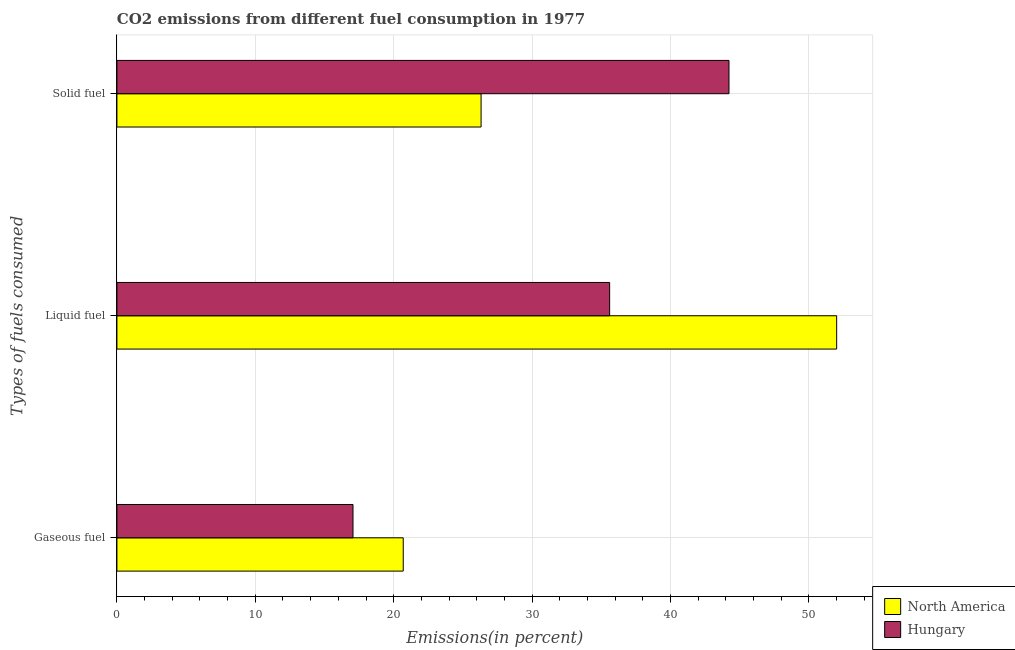How many different coloured bars are there?
Provide a succinct answer. 2. Are the number of bars per tick equal to the number of legend labels?
Give a very brief answer. Yes. Are the number of bars on each tick of the Y-axis equal?
Your response must be concise. Yes. How many bars are there on the 2nd tick from the top?
Give a very brief answer. 2. How many bars are there on the 3rd tick from the bottom?
Provide a short and direct response. 2. What is the label of the 3rd group of bars from the top?
Your response must be concise. Gaseous fuel. What is the percentage of gaseous fuel emission in North America?
Give a very brief answer. 20.69. Across all countries, what is the maximum percentage of liquid fuel emission?
Your response must be concise. 52.01. Across all countries, what is the minimum percentage of liquid fuel emission?
Provide a succinct answer. 35.61. In which country was the percentage of liquid fuel emission minimum?
Your answer should be very brief. Hungary. What is the total percentage of liquid fuel emission in the graph?
Offer a terse response. 87.62. What is the difference between the percentage of gaseous fuel emission in North America and that in Hungary?
Give a very brief answer. 3.63. What is the difference between the percentage of solid fuel emission in Hungary and the percentage of liquid fuel emission in North America?
Give a very brief answer. -7.78. What is the average percentage of liquid fuel emission per country?
Ensure brevity in your answer.  43.81. What is the difference between the percentage of gaseous fuel emission and percentage of solid fuel emission in North America?
Offer a very short reply. -5.63. What is the ratio of the percentage of liquid fuel emission in North America to that in Hungary?
Offer a terse response. 1.46. Is the percentage of solid fuel emission in Hungary less than that in North America?
Offer a very short reply. No. Is the difference between the percentage of gaseous fuel emission in North America and Hungary greater than the difference between the percentage of solid fuel emission in North America and Hungary?
Keep it short and to the point. Yes. What is the difference between the highest and the second highest percentage of liquid fuel emission?
Keep it short and to the point. 16.41. What is the difference between the highest and the lowest percentage of gaseous fuel emission?
Give a very brief answer. 3.63. In how many countries, is the percentage of solid fuel emission greater than the average percentage of solid fuel emission taken over all countries?
Keep it short and to the point. 1. Is the sum of the percentage of solid fuel emission in Hungary and North America greater than the maximum percentage of gaseous fuel emission across all countries?
Offer a very short reply. Yes. What does the 2nd bar from the top in Solid fuel represents?
Offer a terse response. North America. What does the 2nd bar from the bottom in Liquid fuel represents?
Give a very brief answer. Hungary. Is it the case that in every country, the sum of the percentage of gaseous fuel emission and percentage of liquid fuel emission is greater than the percentage of solid fuel emission?
Offer a terse response. Yes. Are all the bars in the graph horizontal?
Provide a short and direct response. Yes. How many countries are there in the graph?
Provide a succinct answer. 2. Does the graph contain any zero values?
Your answer should be very brief. No. Where does the legend appear in the graph?
Ensure brevity in your answer.  Bottom right. How many legend labels are there?
Ensure brevity in your answer.  2. How are the legend labels stacked?
Give a very brief answer. Vertical. What is the title of the graph?
Provide a succinct answer. CO2 emissions from different fuel consumption in 1977. What is the label or title of the X-axis?
Your answer should be compact. Emissions(in percent). What is the label or title of the Y-axis?
Make the answer very short. Types of fuels consumed. What is the Emissions(in percent) of North America in Gaseous fuel?
Provide a succinct answer. 20.69. What is the Emissions(in percent) of Hungary in Gaseous fuel?
Provide a succinct answer. 17.06. What is the Emissions(in percent) in North America in Liquid fuel?
Offer a very short reply. 52.01. What is the Emissions(in percent) of Hungary in Liquid fuel?
Keep it short and to the point. 35.61. What is the Emissions(in percent) in North America in Solid fuel?
Your response must be concise. 26.32. What is the Emissions(in percent) in Hungary in Solid fuel?
Provide a succinct answer. 44.23. Across all Types of fuels consumed, what is the maximum Emissions(in percent) of North America?
Offer a very short reply. 52.01. Across all Types of fuels consumed, what is the maximum Emissions(in percent) in Hungary?
Make the answer very short. 44.23. Across all Types of fuels consumed, what is the minimum Emissions(in percent) in North America?
Give a very brief answer. 20.69. Across all Types of fuels consumed, what is the minimum Emissions(in percent) of Hungary?
Provide a succinct answer. 17.06. What is the total Emissions(in percent) in North America in the graph?
Your response must be concise. 99.02. What is the total Emissions(in percent) of Hungary in the graph?
Offer a terse response. 96.9. What is the difference between the Emissions(in percent) in North America in Gaseous fuel and that in Liquid fuel?
Keep it short and to the point. -31.32. What is the difference between the Emissions(in percent) of Hungary in Gaseous fuel and that in Liquid fuel?
Offer a terse response. -18.55. What is the difference between the Emissions(in percent) in North America in Gaseous fuel and that in Solid fuel?
Your answer should be compact. -5.63. What is the difference between the Emissions(in percent) of Hungary in Gaseous fuel and that in Solid fuel?
Make the answer very short. -27.17. What is the difference between the Emissions(in percent) of North America in Liquid fuel and that in Solid fuel?
Your response must be concise. 25.7. What is the difference between the Emissions(in percent) in Hungary in Liquid fuel and that in Solid fuel?
Offer a terse response. -8.62. What is the difference between the Emissions(in percent) of North America in Gaseous fuel and the Emissions(in percent) of Hungary in Liquid fuel?
Make the answer very short. -14.92. What is the difference between the Emissions(in percent) in North America in Gaseous fuel and the Emissions(in percent) in Hungary in Solid fuel?
Make the answer very short. -23.54. What is the difference between the Emissions(in percent) in North America in Liquid fuel and the Emissions(in percent) in Hungary in Solid fuel?
Your response must be concise. 7.78. What is the average Emissions(in percent) of North America per Types of fuels consumed?
Make the answer very short. 33.01. What is the average Emissions(in percent) in Hungary per Types of fuels consumed?
Provide a short and direct response. 32.3. What is the difference between the Emissions(in percent) in North America and Emissions(in percent) in Hungary in Gaseous fuel?
Provide a short and direct response. 3.63. What is the difference between the Emissions(in percent) in North America and Emissions(in percent) in Hungary in Liquid fuel?
Keep it short and to the point. 16.41. What is the difference between the Emissions(in percent) of North America and Emissions(in percent) of Hungary in Solid fuel?
Ensure brevity in your answer.  -17.92. What is the ratio of the Emissions(in percent) in North America in Gaseous fuel to that in Liquid fuel?
Provide a succinct answer. 0.4. What is the ratio of the Emissions(in percent) of Hungary in Gaseous fuel to that in Liquid fuel?
Ensure brevity in your answer.  0.48. What is the ratio of the Emissions(in percent) in North America in Gaseous fuel to that in Solid fuel?
Give a very brief answer. 0.79. What is the ratio of the Emissions(in percent) of Hungary in Gaseous fuel to that in Solid fuel?
Keep it short and to the point. 0.39. What is the ratio of the Emissions(in percent) in North America in Liquid fuel to that in Solid fuel?
Provide a succinct answer. 1.98. What is the ratio of the Emissions(in percent) of Hungary in Liquid fuel to that in Solid fuel?
Keep it short and to the point. 0.81. What is the difference between the highest and the second highest Emissions(in percent) in North America?
Offer a terse response. 25.7. What is the difference between the highest and the second highest Emissions(in percent) of Hungary?
Provide a short and direct response. 8.62. What is the difference between the highest and the lowest Emissions(in percent) of North America?
Ensure brevity in your answer.  31.32. What is the difference between the highest and the lowest Emissions(in percent) of Hungary?
Your answer should be compact. 27.17. 